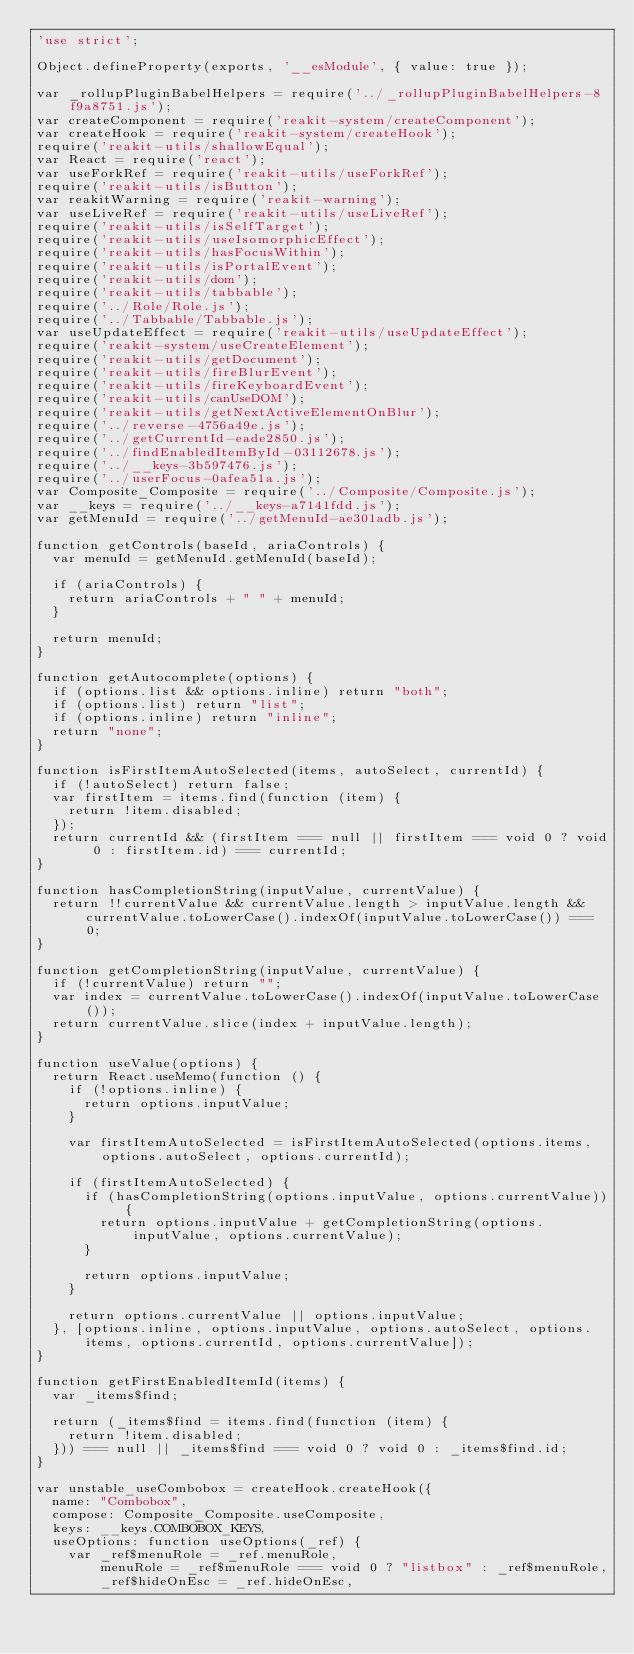<code> <loc_0><loc_0><loc_500><loc_500><_JavaScript_>'use strict';

Object.defineProperty(exports, '__esModule', { value: true });

var _rollupPluginBabelHelpers = require('../_rollupPluginBabelHelpers-8f9a8751.js');
var createComponent = require('reakit-system/createComponent');
var createHook = require('reakit-system/createHook');
require('reakit-utils/shallowEqual');
var React = require('react');
var useForkRef = require('reakit-utils/useForkRef');
require('reakit-utils/isButton');
var reakitWarning = require('reakit-warning');
var useLiveRef = require('reakit-utils/useLiveRef');
require('reakit-utils/isSelfTarget');
require('reakit-utils/useIsomorphicEffect');
require('reakit-utils/hasFocusWithin');
require('reakit-utils/isPortalEvent');
require('reakit-utils/dom');
require('reakit-utils/tabbable');
require('../Role/Role.js');
require('../Tabbable/Tabbable.js');
var useUpdateEffect = require('reakit-utils/useUpdateEffect');
require('reakit-system/useCreateElement');
require('reakit-utils/getDocument');
require('reakit-utils/fireBlurEvent');
require('reakit-utils/fireKeyboardEvent');
require('reakit-utils/canUseDOM');
require('reakit-utils/getNextActiveElementOnBlur');
require('../reverse-4756a49e.js');
require('../getCurrentId-eade2850.js');
require('../findEnabledItemById-03112678.js');
require('../__keys-3b597476.js');
require('../userFocus-0afea51a.js');
var Composite_Composite = require('../Composite/Composite.js');
var __keys = require('../__keys-a7141fdd.js');
var getMenuId = require('../getMenuId-ae301adb.js');

function getControls(baseId, ariaControls) {
  var menuId = getMenuId.getMenuId(baseId);

  if (ariaControls) {
    return ariaControls + " " + menuId;
  }

  return menuId;
}

function getAutocomplete(options) {
  if (options.list && options.inline) return "both";
  if (options.list) return "list";
  if (options.inline) return "inline";
  return "none";
}

function isFirstItemAutoSelected(items, autoSelect, currentId) {
  if (!autoSelect) return false;
  var firstItem = items.find(function (item) {
    return !item.disabled;
  });
  return currentId && (firstItem === null || firstItem === void 0 ? void 0 : firstItem.id) === currentId;
}

function hasCompletionString(inputValue, currentValue) {
  return !!currentValue && currentValue.length > inputValue.length && currentValue.toLowerCase().indexOf(inputValue.toLowerCase()) === 0;
}

function getCompletionString(inputValue, currentValue) {
  if (!currentValue) return "";
  var index = currentValue.toLowerCase().indexOf(inputValue.toLowerCase());
  return currentValue.slice(index + inputValue.length);
}

function useValue(options) {
  return React.useMemo(function () {
    if (!options.inline) {
      return options.inputValue;
    }

    var firstItemAutoSelected = isFirstItemAutoSelected(options.items, options.autoSelect, options.currentId);

    if (firstItemAutoSelected) {
      if (hasCompletionString(options.inputValue, options.currentValue)) {
        return options.inputValue + getCompletionString(options.inputValue, options.currentValue);
      }

      return options.inputValue;
    }

    return options.currentValue || options.inputValue;
  }, [options.inline, options.inputValue, options.autoSelect, options.items, options.currentId, options.currentValue]);
}

function getFirstEnabledItemId(items) {
  var _items$find;

  return (_items$find = items.find(function (item) {
    return !item.disabled;
  })) === null || _items$find === void 0 ? void 0 : _items$find.id;
}

var unstable_useCombobox = createHook.createHook({
  name: "Combobox",
  compose: Composite_Composite.useComposite,
  keys: __keys.COMBOBOX_KEYS,
  useOptions: function useOptions(_ref) {
    var _ref$menuRole = _ref.menuRole,
        menuRole = _ref$menuRole === void 0 ? "listbox" : _ref$menuRole,
        _ref$hideOnEsc = _ref.hideOnEsc,</code> 